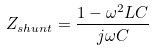Convert formula to latex. <formula><loc_0><loc_0><loc_500><loc_500>Z _ { s h u n t } = { \frac { 1 - \omega ^ { 2 } L C } { j \omega C } }</formula> 